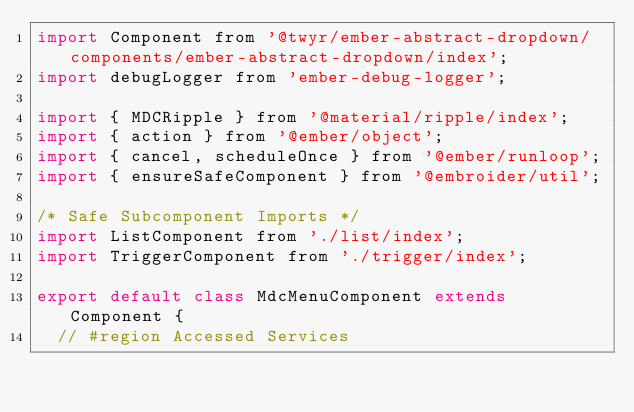<code> <loc_0><loc_0><loc_500><loc_500><_JavaScript_>import Component from '@twyr/ember-abstract-dropdown/components/ember-abstract-dropdown/index';
import debugLogger from 'ember-debug-logger';

import { MDCRipple } from '@material/ripple/index';
import { action } from '@ember/object';
import { cancel, scheduleOnce } from '@ember/runloop';
import { ensureSafeComponent } from '@embroider/util';

/* Safe Subcomponent Imports */
import ListComponent from './list/index';
import TriggerComponent from './trigger/index';

export default class MdcMenuComponent extends Component {
	// #region Accessed Services</code> 